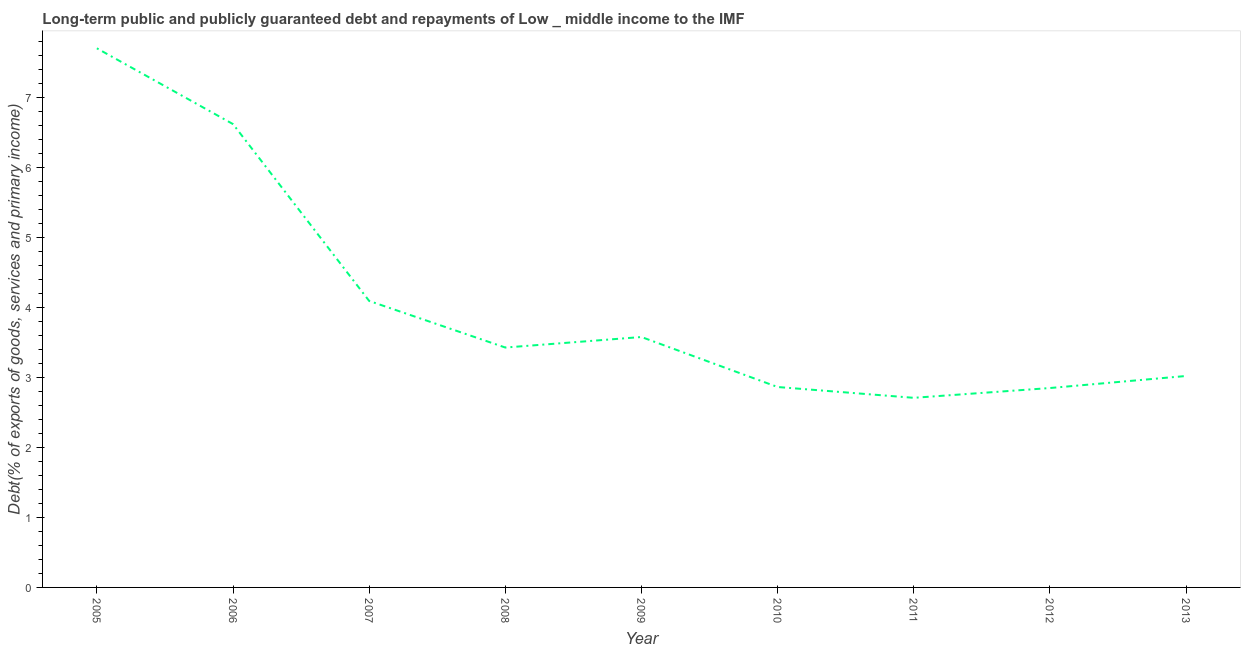What is the debt service in 2010?
Provide a succinct answer. 2.87. Across all years, what is the maximum debt service?
Keep it short and to the point. 7.71. Across all years, what is the minimum debt service?
Your response must be concise. 2.71. In which year was the debt service maximum?
Make the answer very short. 2005. What is the sum of the debt service?
Keep it short and to the point. 36.89. What is the difference between the debt service in 2007 and 2010?
Offer a very short reply. 1.23. What is the average debt service per year?
Ensure brevity in your answer.  4.1. What is the median debt service?
Provide a succinct answer. 3.43. Do a majority of the years between 2013 and 2009 (inclusive) have debt service greater than 6.8 %?
Give a very brief answer. Yes. What is the ratio of the debt service in 2011 to that in 2013?
Make the answer very short. 0.9. Is the debt service in 2006 less than that in 2013?
Ensure brevity in your answer.  No. Is the difference between the debt service in 2005 and 2008 greater than the difference between any two years?
Your answer should be compact. No. What is the difference between the highest and the second highest debt service?
Keep it short and to the point. 1.08. Is the sum of the debt service in 2005 and 2006 greater than the maximum debt service across all years?
Make the answer very short. Yes. What is the difference between the highest and the lowest debt service?
Your answer should be compact. 5. In how many years, is the debt service greater than the average debt service taken over all years?
Provide a succinct answer. 2. Does the debt service monotonically increase over the years?
Provide a short and direct response. No. How many lines are there?
Ensure brevity in your answer.  1. How many years are there in the graph?
Ensure brevity in your answer.  9. Does the graph contain grids?
Your answer should be compact. No. What is the title of the graph?
Give a very brief answer. Long-term public and publicly guaranteed debt and repayments of Low _ middle income to the IMF. What is the label or title of the Y-axis?
Your response must be concise. Debt(% of exports of goods, services and primary income). What is the Debt(% of exports of goods, services and primary income) in 2005?
Give a very brief answer. 7.71. What is the Debt(% of exports of goods, services and primary income) of 2006?
Your response must be concise. 6.62. What is the Debt(% of exports of goods, services and primary income) in 2007?
Offer a very short reply. 4.1. What is the Debt(% of exports of goods, services and primary income) of 2008?
Ensure brevity in your answer.  3.43. What is the Debt(% of exports of goods, services and primary income) in 2009?
Keep it short and to the point. 3.58. What is the Debt(% of exports of goods, services and primary income) of 2010?
Provide a short and direct response. 2.87. What is the Debt(% of exports of goods, services and primary income) in 2011?
Give a very brief answer. 2.71. What is the Debt(% of exports of goods, services and primary income) in 2012?
Offer a very short reply. 2.85. What is the Debt(% of exports of goods, services and primary income) of 2013?
Make the answer very short. 3.02. What is the difference between the Debt(% of exports of goods, services and primary income) in 2005 and 2006?
Provide a short and direct response. 1.08. What is the difference between the Debt(% of exports of goods, services and primary income) in 2005 and 2007?
Offer a very short reply. 3.61. What is the difference between the Debt(% of exports of goods, services and primary income) in 2005 and 2008?
Give a very brief answer. 4.28. What is the difference between the Debt(% of exports of goods, services and primary income) in 2005 and 2009?
Your answer should be compact. 4.13. What is the difference between the Debt(% of exports of goods, services and primary income) in 2005 and 2010?
Offer a terse response. 4.84. What is the difference between the Debt(% of exports of goods, services and primary income) in 2005 and 2011?
Offer a very short reply. 5. What is the difference between the Debt(% of exports of goods, services and primary income) in 2005 and 2012?
Make the answer very short. 4.86. What is the difference between the Debt(% of exports of goods, services and primary income) in 2005 and 2013?
Ensure brevity in your answer.  4.69. What is the difference between the Debt(% of exports of goods, services and primary income) in 2006 and 2007?
Keep it short and to the point. 2.53. What is the difference between the Debt(% of exports of goods, services and primary income) in 2006 and 2008?
Keep it short and to the point. 3.19. What is the difference between the Debt(% of exports of goods, services and primary income) in 2006 and 2009?
Make the answer very short. 3.04. What is the difference between the Debt(% of exports of goods, services and primary income) in 2006 and 2010?
Ensure brevity in your answer.  3.76. What is the difference between the Debt(% of exports of goods, services and primary income) in 2006 and 2011?
Your answer should be compact. 3.91. What is the difference between the Debt(% of exports of goods, services and primary income) in 2006 and 2012?
Offer a terse response. 3.77. What is the difference between the Debt(% of exports of goods, services and primary income) in 2006 and 2013?
Your response must be concise. 3.6. What is the difference between the Debt(% of exports of goods, services and primary income) in 2007 and 2008?
Ensure brevity in your answer.  0.67. What is the difference between the Debt(% of exports of goods, services and primary income) in 2007 and 2009?
Give a very brief answer. 0.52. What is the difference between the Debt(% of exports of goods, services and primary income) in 2007 and 2010?
Keep it short and to the point. 1.23. What is the difference between the Debt(% of exports of goods, services and primary income) in 2007 and 2011?
Your answer should be compact. 1.39. What is the difference between the Debt(% of exports of goods, services and primary income) in 2007 and 2012?
Provide a short and direct response. 1.25. What is the difference between the Debt(% of exports of goods, services and primary income) in 2007 and 2013?
Provide a short and direct response. 1.07. What is the difference between the Debt(% of exports of goods, services and primary income) in 2008 and 2009?
Your answer should be compact. -0.15. What is the difference between the Debt(% of exports of goods, services and primary income) in 2008 and 2010?
Your response must be concise. 0.56. What is the difference between the Debt(% of exports of goods, services and primary income) in 2008 and 2011?
Give a very brief answer. 0.72. What is the difference between the Debt(% of exports of goods, services and primary income) in 2008 and 2012?
Offer a very short reply. 0.58. What is the difference between the Debt(% of exports of goods, services and primary income) in 2008 and 2013?
Your response must be concise. 0.41. What is the difference between the Debt(% of exports of goods, services and primary income) in 2009 and 2010?
Provide a succinct answer. 0.71. What is the difference between the Debt(% of exports of goods, services and primary income) in 2009 and 2011?
Make the answer very short. 0.87. What is the difference between the Debt(% of exports of goods, services and primary income) in 2009 and 2012?
Your answer should be very brief. 0.73. What is the difference between the Debt(% of exports of goods, services and primary income) in 2009 and 2013?
Give a very brief answer. 0.56. What is the difference between the Debt(% of exports of goods, services and primary income) in 2010 and 2011?
Offer a terse response. 0.15. What is the difference between the Debt(% of exports of goods, services and primary income) in 2010 and 2012?
Your answer should be compact. 0.01. What is the difference between the Debt(% of exports of goods, services and primary income) in 2010 and 2013?
Your answer should be very brief. -0.16. What is the difference between the Debt(% of exports of goods, services and primary income) in 2011 and 2012?
Provide a succinct answer. -0.14. What is the difference between the Debt(% of exports of goods, services and primary income) in 2011 and 2013?
Keep it short and to the point. -0.31. What is the difference between the Debt(% of exports of goods, services and primary income) in 2012 and 2013?
Offer a terse response. -0.17. What is the ratio of the Debt(% of exports of goods, services and primary income) in 2005 to that in 2006?
Offer a very short reply. 1.16. What is the ratio of the Debt(% of exports of goods, services and primary income) in 2005 to that in 2007?
Your response must be concise. 1.88. What is the ratio of the Debt(% of exports of goods, services and primary income) in 2005 to that in 2008?
Make the answer very short. 2.25. What is the ratio of the Debt(% of exports of goods, services and primary income) in 2005 to that in 2009?
Your answer should be compact. 2.15. What is the ratio of the Debt(% of exports of goods, services and primary income) in 2005 to that in 2010?
Your answer should be compact. 2.69. What is the ratio of the Debt(% of exports of goods, services and primary income) in 2005 to that in 2011?
Make the answer very short. 2.84. What is the ratio of the Debt(% of exports of goods, services and primary income) in 2005 to that in 2012?
Your response must be concise. 2.7. What is the ratio of the Debt(% of exports of goods, services and primary income) in 2005 to that in 2013?
Keep it short and to the point. 2.55. What is the ratio of the Debt(% of exports of goods, services and primary income) in 2006 to that in 2007?
Your answer should be compact. 1.62. What is the ratio of the Debt(% of exports of goods, services and primary income) in 2006 to that in 2008?
Offer a terse response. 1.93. What is the ratio of the Debt(% of exports of goods, services and primary income) in 2006 to that in 2009?
Provide a short and direct response. 1.85. What is the ratio of the Debt(% of exports of goods, services and primary income) in 2006 to that in 2010?
Offer a very short reply. 2.31. What is the ratio of the Debt(% of exports of goods, services and primary income) in 2006 to that in 2011?
Your answer should be very brief. 2.44. What is the ratio of the Debt(% of exports of goods, services and primary income) in 2006 to that in 2012?
Give a very brief answer. 2.32. What is the ratio of the Debt(% of exports of goods, services and primary income) in 2006 to that in 2013?
Your answer should be very brief. 2.19. What is the ratio of the Debt(% of exports of goods, services and primary income) in 2007 to that in 2008?
Provide a succinct answer. 1.19. What is the ratio of the Debt(% of exports of goods, services and primary income) in 2007 to that in 2009?
Offer a very short reply. 1.14. What is the ratio of the Debt(% of exports of goods, services and primary income) in 2007 to that in 2010?
Your answer should be very brief. 1.43. What is the ratio of the Debt(% of exports of goods, services and primary income) in 2007 to that in 2011?
Provide a short and direct response. 1.51. What is the ratio of the Debt(% of exports of goods, services and primary income) in 2007 to that in 2012?
Your answer should be very brief. 1.44. What is the ratio of the Debt(% of exports of goods, services and primary income) in 2007 to that in 2013?
Provide a succinct answer. 1.35. What is the ratio of the Debt(% of exports of goods, services and primary income) in 2008 to that in 2009?
Make the answer very short. 0.96. What is the ratio of the Debt(% of exports of goods, services and primary income) in 2008 to that in 2010?
Make the answer very short. 1.2. What is the ratio of the Debt(% of exports of goods, services and primary income) in 2008 to that in 2011?
Make the answer very short. 1.26. What is the ratio of the Debt(% of exports of goods, services and primary income) in 2008 to that in 2012?
Make the answer very short. 1.2. What is the ratio of the Debt(% of exports of goods, services and primary income) in 2008 to that in 2013?
Your answer should be compact. 1.14. What is the ratio of the Debt(% of exports of goods, services and primary income) in 2009 to that in 2010?
Your answer should be compact. 1.25. What is the ratio of the Debt(% of exports of goods, services and primary income) in 2009 to that in 2011?
Your response must be concise. 1.32. What is the ratio of the Debt(% of exports of goods, services and primary income) in 2009 to that in 2012?
Give a very brief answer. 1.26. What is the ratio of the Debt(% of exports of goods, services and primary income) in 2009 to that in 2013?
Provide a short and direct response. 1.18. What is the ratio of the Debt(% of exports of goods, services and primary income) in 2010 to that in 2011?
Keep it short and to the point. 1.06. What is the ratio of the Debt(% of exports of goods, services and primary income) in 2010 to that in 2013?
Provide a succinct answer. 0.95. What is the ratio of the Debt(% of exports of goods, services and primary income) in 2011 to that in 2012?
Offer a very short reply. 0.95. What is the ratio of the Debt(% of exports of goods, services and primary income) in 2011 to that in 2013?
Your response must be concise. 0.9. What is the ratio of the Debt(% of exports of goods, services and primary income) in 2012 to that in 2013?
Provide a short and direct response. 0.94. 